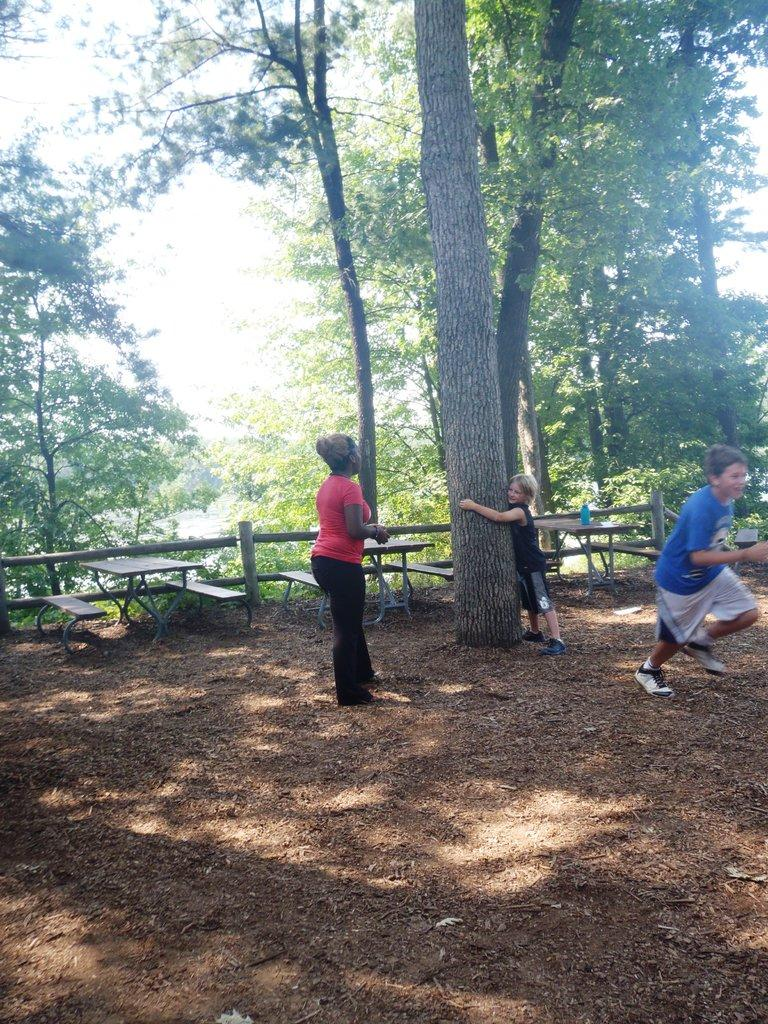What type of natural elements can be seen in the image? There are trees in the image. How many people are present in the image? There are two people on the ground in the image. What type of seating is available in the image? There are benches in the image. Where is the cellar located in the image? There is no cellar present in the image. Which direction is north in the image? The image does not provide any information about the direction of north. 